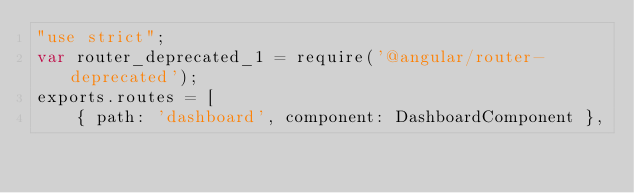<code> <loc_0><loc_0><loc_500><loc_500><_JavaScript_>"use strict";
var router_deprecated_1 = require('@angular/router-deprecated');
exports.routes = [
    { path: 'dashboard', component: DashboardComponent },</code> 